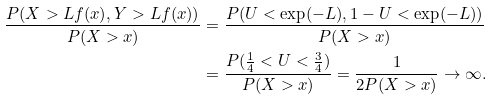Convert formula to latex. <formula><loc_0><loc_0><loc_500><loc_500>\frac { P ( X > L f ( x ) , Y > L f ( x ) ) } { P ( X > x ) } & = \frac { P ( U < \exp ( - L ) , 1 - U < \exp ( - L ) ) } { P ( X > x ) } \\ & = \frac { P ( \frac { 1 } { 4 } < U < \frac { 3 } { 4 } ) } { P ( X > x ) } = \frac { 1 } { 2 P ( X > x ) } \rightarrow \infty .</formula> 